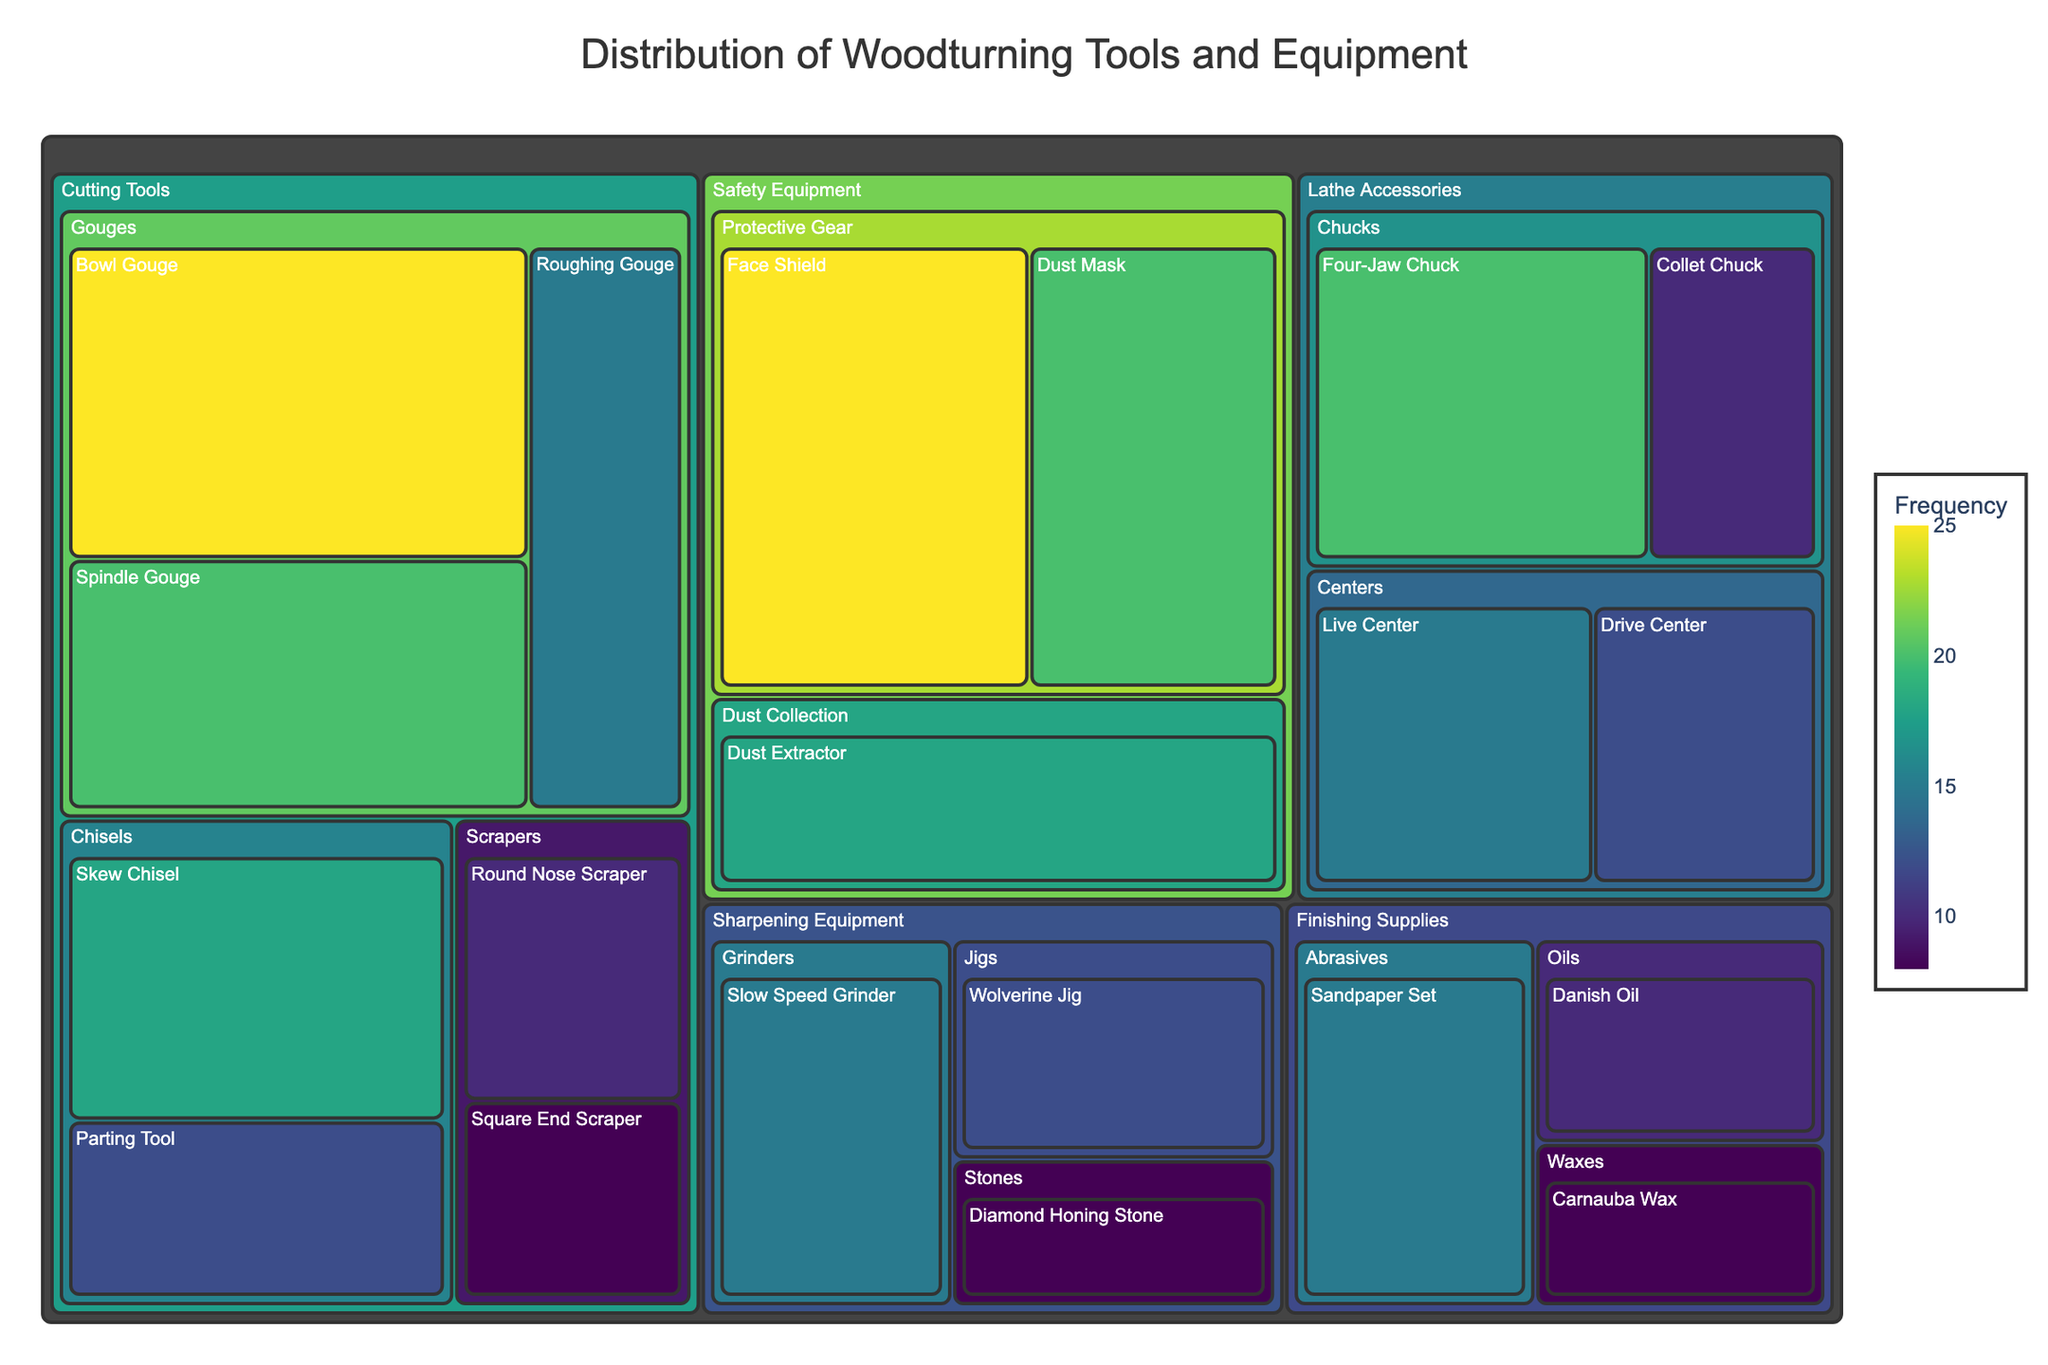What's the most frequently used tool in the workshop? The figure's color intensity indicates the frequency of use, with darker colors representing higher frequencies. The largest and darkest segment is the "Face Shield" under "Safety Equipment, Protective Gear" with a frequency value of 25.
Answer: Face Shield What's the combined frequency of all the "Chisels" in the workshop? Adding the frequency values from each "Chisel" tool: Skew Chisel (18) + Parting Tool (12), we get 18 + 12 = 30.
Answer: 30 Which category has the highest number of subcategories? By examining the segments and their hierarchical paths in the treemap, "Cutting Tools" has the most subcategories with three: Gouges, Chisels, and Scrapers.
Answer: Cutting Tools Is the "Dust Extractor" more frequently used than the "Danish Oil"? The "Dust Extractor" under "Safety Equipment, Dust Collection" has a frequency value of 18, while "Danish Oil" under "Finishing Supplies, Oils" has a frequency value of 10. Since 18 > 10, the Dust Extractor is used more frequently.
Answer: Yes What is the sum of frequencies for all "Gouges"? Adding the frequency values of each "Gouge": Bowl Gouge (25) + Spindle Gouge (20) + Roughing Gouge (15), we get 25 + 20 + 15 = 60.
Answer: 60 Which tool under "Sharpening Equipment" is used the least? Under "Sharpening Equipment", the tools are Slow Speed Grinder (15), Wolverine Jig (12), Diamond Honing Stone (8). The least used is the "Diamond Honing Stone" with a value of 8.
Answer: Diamond Honing Stone How does the frequency of the "Four-Jaw Chuck" compare to the "Live Center"? The "Four-Jaw Chuck" under "Lathe Accessories, Chucks" has a frequency of 20, while the "Live Center" under "Lathe Accessories, Centers" has a frequency of 15. Since 20 > 15, the Four-Jaw Chuck is used more frequently.
Answer: Four-Jaw Chuck What's the average frequency of tools under "Finishing Supplies"? The tools under "Finishing Supplies" are Sandpaper Set (15), Danish Oil (10), and Carnauba Wax (8). The average is (15 + 10 + 8)/3 = 33/3 = 11.
Answer: 11 Which safety equipment is used more frequently, the "Face Shield" or the "Dust Mask"? Both the "Face Shield" and the "Dust Mask" fall under "Safety Equipment, Protective Gear" and each has a frequency value of 25 and 20, respectively. Since 25 > 20, the Face Shield is used more frequently.
Answer: Face Shield 